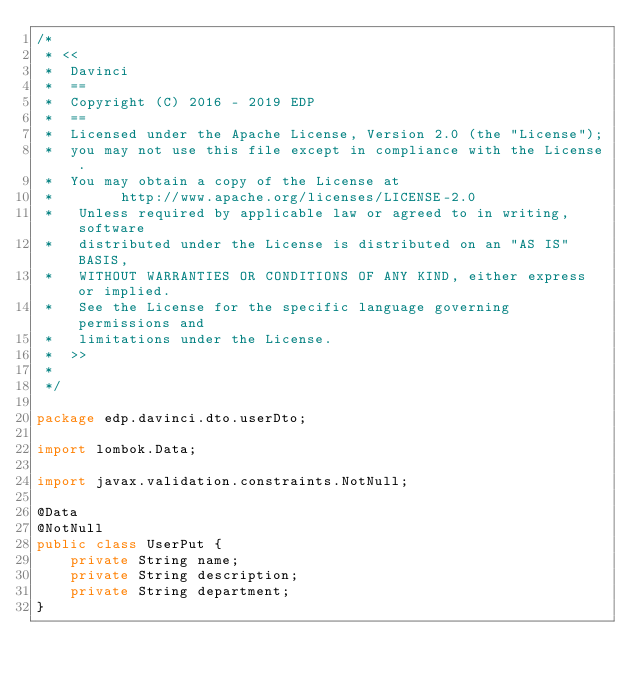<code> <loc_0><loc_0><loc_500><loc_500><_Java_>/*
 * <<
 *  Davinci
 *  ==
 *  Copyright (C) 2016 - 2019 EDP
 *  ==
 *  Licensed under the Apache License, Version 2.0 (the "License");
 *  you may not use this file except in compliance with the License.
 *  You may obtain a copy of the License at
 *        http://www.apache.org/licenses/LICENSE-2.0
 *   Unless required by applicable law or agreed to in writing, software
 *   distributed under the License is distributed on an "AS IS" BASIS,
 *   WITHOUT WARRANTIES OR CONDITIONS OF ANY KIND, either express or implied.
 *   See the License for the specific language governing permissions and
 *   limitations under the License.
 *  >>
 *
 */

package edp.davinci.dto.userDto;

import lombok.Data;

import javax.validation.constraints.NotNull;

@Data
@NotNull
public class UserPut {
    private String name;
    private String description;
    private String department;
}
</code> 